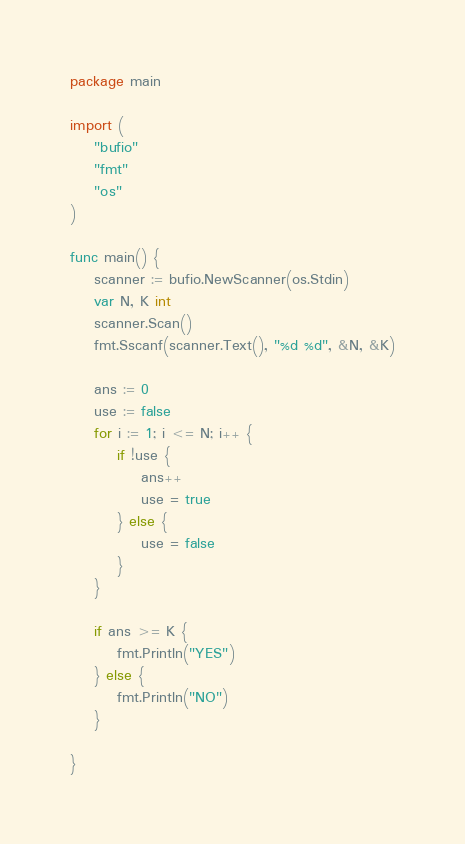<code> <loc_0><loc_0><loc_500><loc_500><_Go_>package main

import (
	"bufio"
	"fmt"
	"os"
)

func main() {
	scanner := bufio.NewScanner(os.Stdin)
	var N, K int
	scanner.Scan()
	fmt.Sscanf(scanner.Text(), "%d %d", &N, &K)

	ans := 0
	use := false
	for i := 1; i <= N; i++ {
		if !use {
			ans++
			use = true
		} else {
			use = false
		}
	}

	if ans >= K {
		fmt.Println("YES")
	} else {
		fmt.Println("NO")
	}

}
</code> 